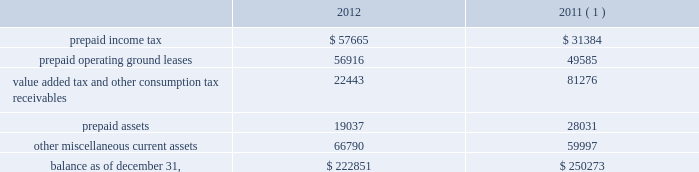American tower corporation and subsidiaries notes to consolidated financial statements loss on retirement of long-term obligations 2014loss on retirement of long-term obligations primarily includes cash paid to retire debt in excess of its carrying value , cash paid to holders of convertible notes in connection with note conversions and non-cash charges related to the write-off of deferred financing fees .
Loss on retirement of long-term obligations also includes gains from repurchasing or refinancing certain of the company 2019s debt obligations .
Earnings per common share 2014basic and diluted 2014basic income from continuing operations per common share for the years ended december 31 , 2012 , 2011 and 2010 represents income from continuing operations attributable to american tower corporation divided by the weighted average number of common shares outstanding during the period .
Diluted income from continuing operations per common share for the years ended december 31 , 2012 , 2011 and 2010 represents income from continuing operations attributable to american tower corporation divided by the weighted average number of common shares outstanding during the period and any dilutive common share equivalents , including unvested restricted stock , shares issuable upon exercise of stock options and warrants as determined under the treasury stock method and upon conversion of the company 2019s convertible notes , as determined under the if-converted method .
Retirement plan 2014the company has a 401 ( k ) plan covering substantially all employees who meet certain age and employment requirements .
The company 2019s matching contribution for the years ended december 31 , 2012 , 2011 and 2010 is 50% ( 50 % ) up to a maximum 6% ( 6 % ) of a participant 2019s contributions .
For the years ended december 31 , 2012 , 2011 and 2010 , the company contributed approximately $ 4.4 million , $ 2.9 million and $ 1.9 million to the plan , respectively .
Prepaid and other current assets prepaid and other current assets consist of the following as of december 31 , ( in thousands ) : .
( 1 ) december 31 , 2011 balances have been revised to reflect purchase accounting measurement period adjustments. .
What was the average company contribution to the retirement plan from 2010 to 2012? 
Computations: ((1.9 + (4.4 / 2.9)) / 3)
Answer: 1.13908. 